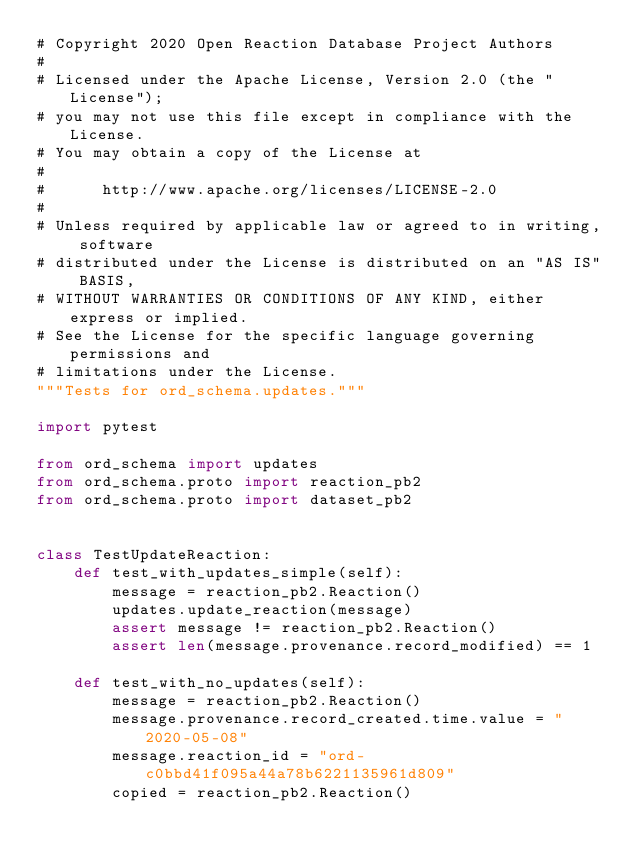<code> <loc_0><loc_0><loc_500><loc_500><_Python_># Copyright 2020 Open Reaction Database Project Authors
#
# Licensed under the Apache License, Version 2.0 (the "License");
# you may not use this file except in compliance with the License.
# You may obtain a copy of the License at
#
#      http://www.apache.org/licenses/LICENSE-2.0
#
# Unless required by applicable law or agreed to in writing, software
# distributed under the License is distributed on an "AS IS" BASIS,
# WITHOUT WARRANTIES OR CONDITIONS OF ANY KIND, either express or implied.
# See the License for the specific language governing permissions and
# limitations under the License.
"""Tests for ord_schema.updates."""

import pytest

from ord_schema import updates
from ord_schema.proto import reaction_pb2
from ord_schema.proto import dataset_pb2


class TestUpdateReaction:
    def test_with_updates_simple(self):
        message = reaction_pb2.Reaction()
        updates.update_reaction(message)
        assert message != reaction_pb2.Reaction()
        assert len(message.provenance.record_modified) == 1

    def test_with_no_updates(self):
        message = reaction_pb2.Reaction()
        message.provenance.record_created.time.value = "2020-05-08"
        message.reaction_id = "ord-c0bbd41f095a44a78b6221135961d809"
        copied = reaction_pb2.Reaction()</code> 